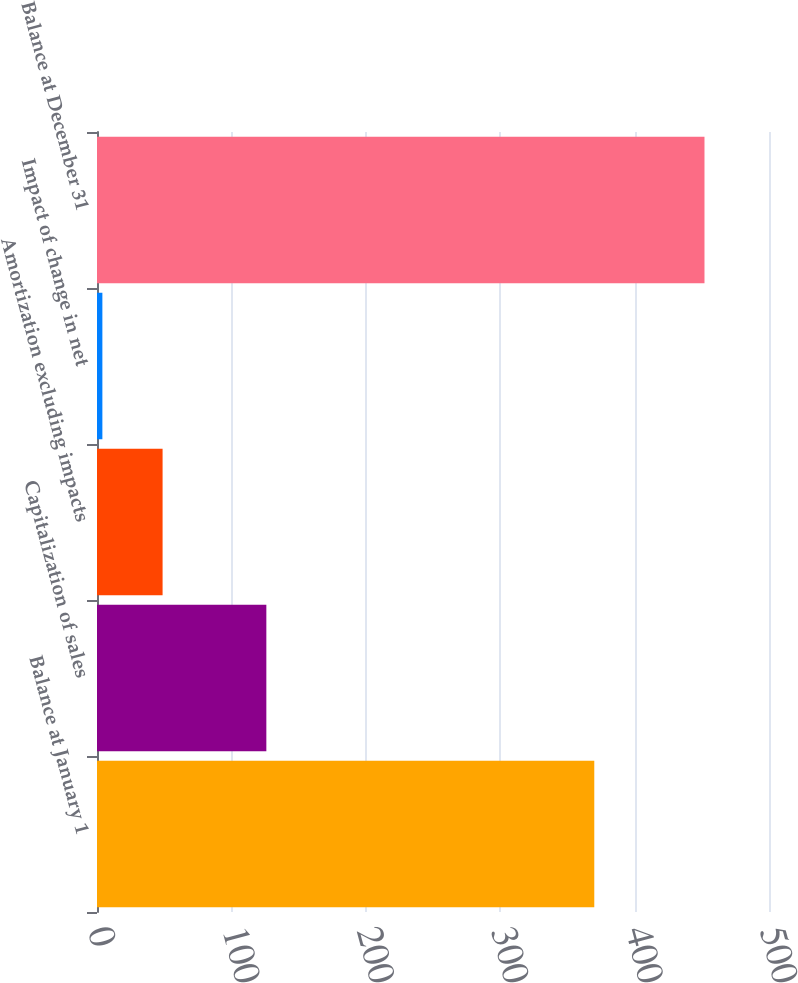<chart> <loc_0><loc_0><loc_500><loc_500><bar_chart><fcel>Balance at January 1<fcel>Capitalization of sales<fcel>Amortization excluding impacts<fcel>Impact of change in net<fcel>Balance at December 31<nl><fcel>370<fcel>126<fcel>48.8<fcel>4<fcel>452<nl></chart> 